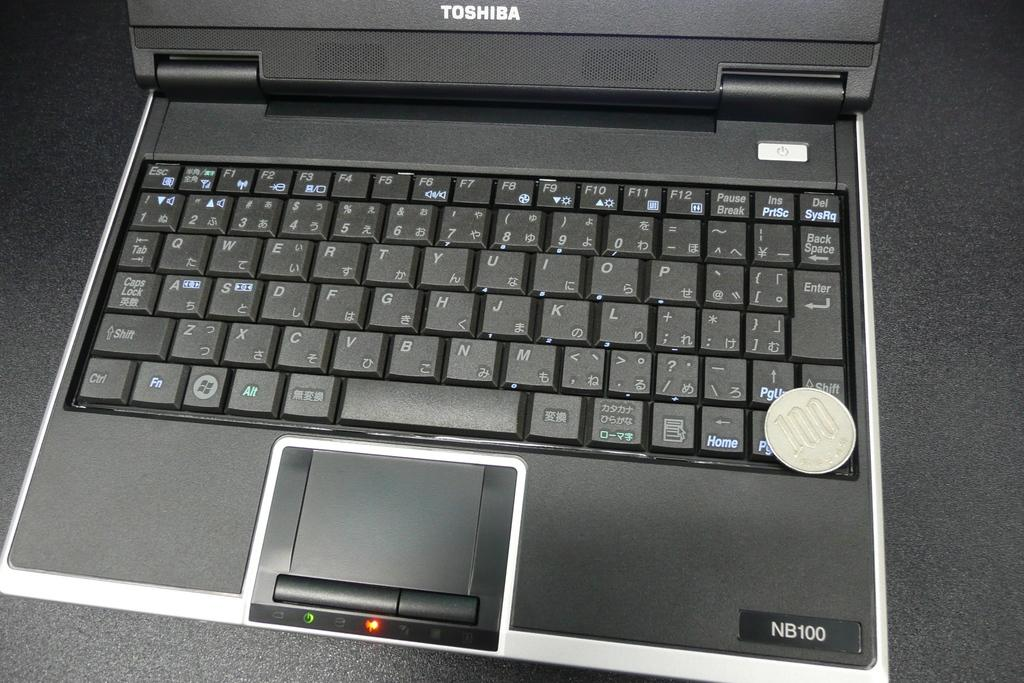<image>
Share a concise interpretation of the image provided. A Toshiba brand laptop with a type of NB100 in the bottom corner. 